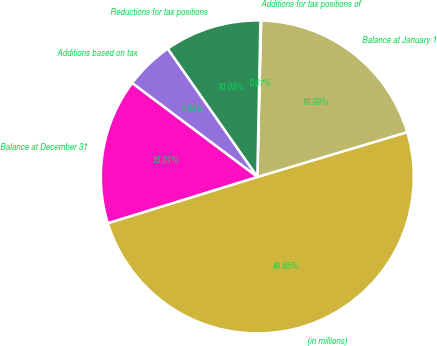<chart> <loc_0><loc_0><loc_500><loc_500><pie_chart><fcel>(in millions)<fcel>Balance at January 1<fcel>Additions for tax positions of<fcel>Reductions for tax positions<fcel>Additions based on tax<fcel>Balance at December 31<nl><fcel>49.85%<fcel>19.99%<fcel>0.07%<fcel>10.03%<fcel>5.05%<fcel>15.01%<nl></chart> 